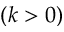<formula> <loc_0><loc_0><loc_500><loc_500>( k > 0 )</formula> 